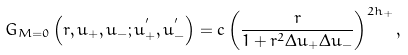<formula> <loc_0><loc_0><loc_500><loc_500>G _ { M = 0 } \left ( { r , u _ { + } , u _ { - } ; u _ { + } ^ { ^ { \prime } } , u _ { - } ^ { ^ { \prime } } } \right ) = c \left ( { \frac { r } { 1 + r ^ { 2 } \Delta u _ { + } \Delta u _ { - } } } \right ) ^ { 2 h _ { + } } ,</formula> 